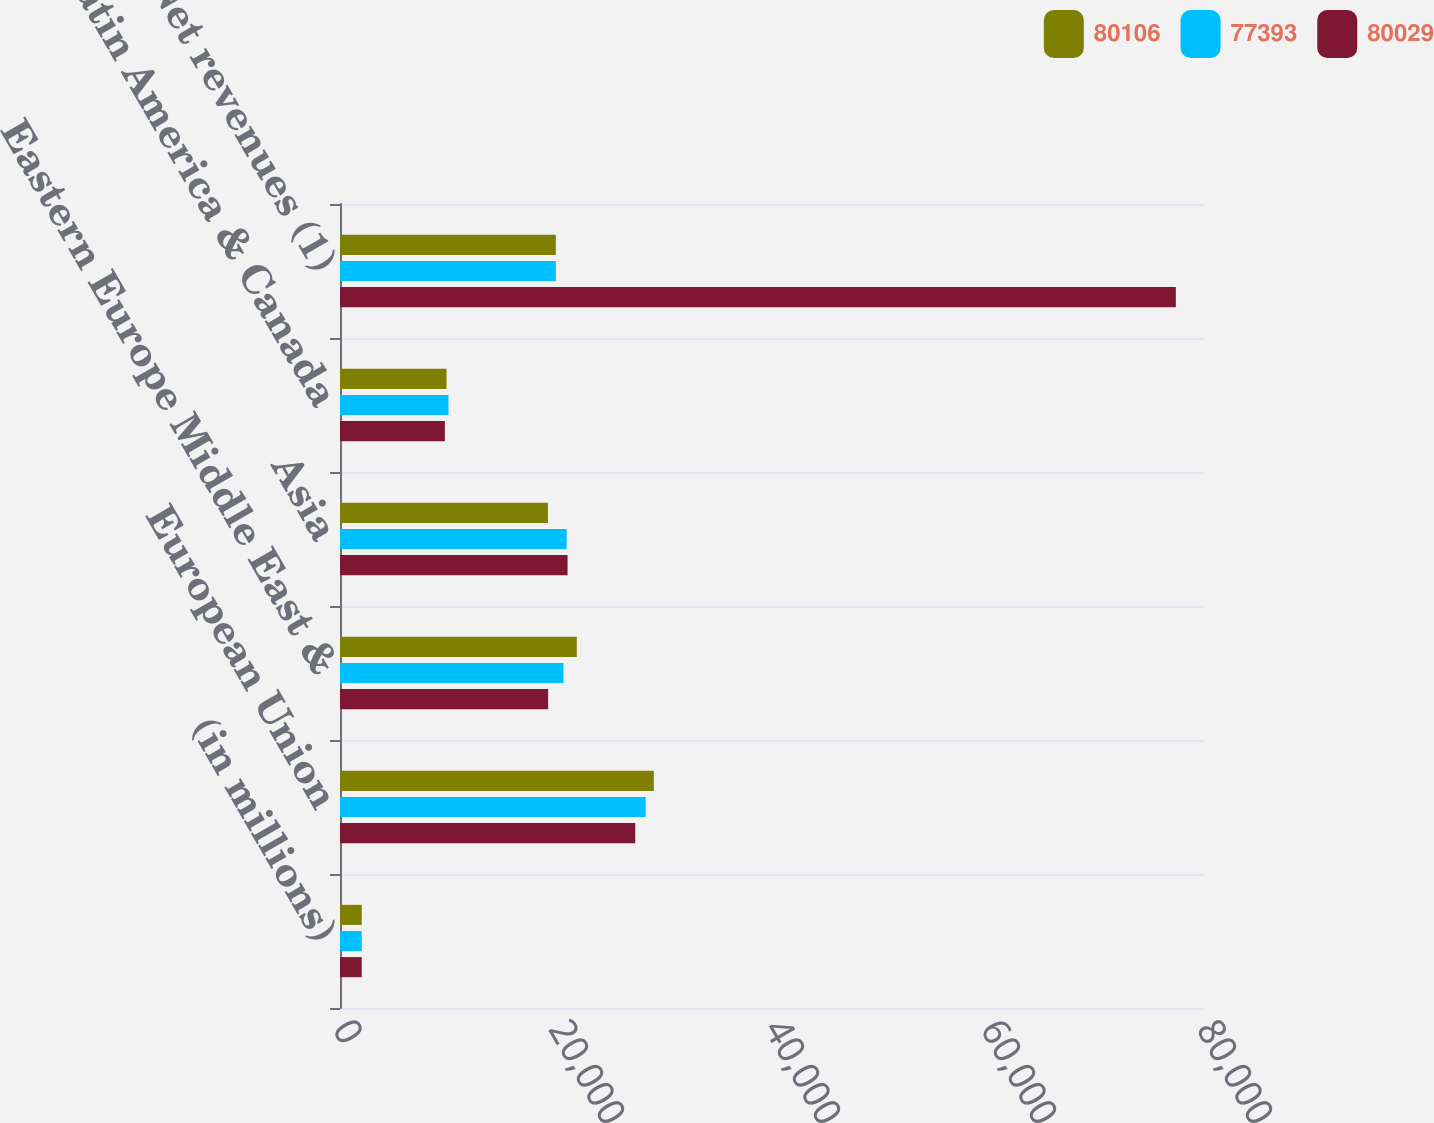Convert chart to OTSL. <chart><loc_0><loc_0><loc_500><loc_500><stacked_bar_chart><ecel><fcel>(in millions)<fcel>European Union<fcel>Eastern Europe Middle East &<fcel>Asia<fcel>Latin America & Canada<fcel>Net revenues (1)<nl><fcel>80106<fcel>2014<fcel>29058<fcel>21928<fcel>19255<fcel>9865<fcel>19983.5<nl><fcel>77393<fcel>2013<fcel>28303<fcel>20695<fcel>20987<fcel>10044<fcel>19983.5<nl><fcel>80029<fcel>2012<fcel>27338<fcel>19272<fcel>21071<fcel>9712<fcel>77393<nl></chart> 